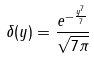<formula> <loc_0><loc_0><loc_500><loc_500>\delta ( y ) = \frac { e ^ { - \frac { y ^ { 7 } } { 7 } } } { \sqrt { 7 \pi } }</formula> 